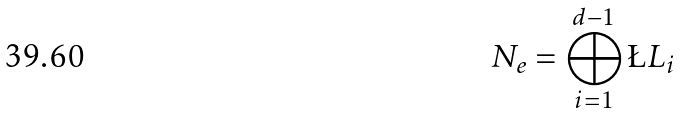<formula> <loc_0><loc_0><loc_500><loc_500>N _ { e } = \bigoplus _ { i = 1 } ^ { d - 1 } \L L _ { i }</formula> 